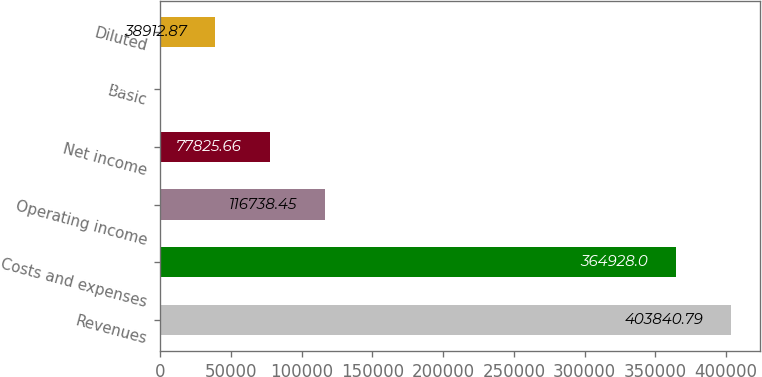Convert chart to OTSL. <chart><loc_0><loc_0><loc_500><loc_500><bar_chart><fcel>Revenues<fcel>Costs and expenses<fcel>Operating income<fcel>Net income<fcel>Basic<fcel>Diluted<nl><fcel>403841<fcel>364928<fcel>116738<fcel>77825.7<fcel>0.08<fcel>38912.9<nl></chart> 